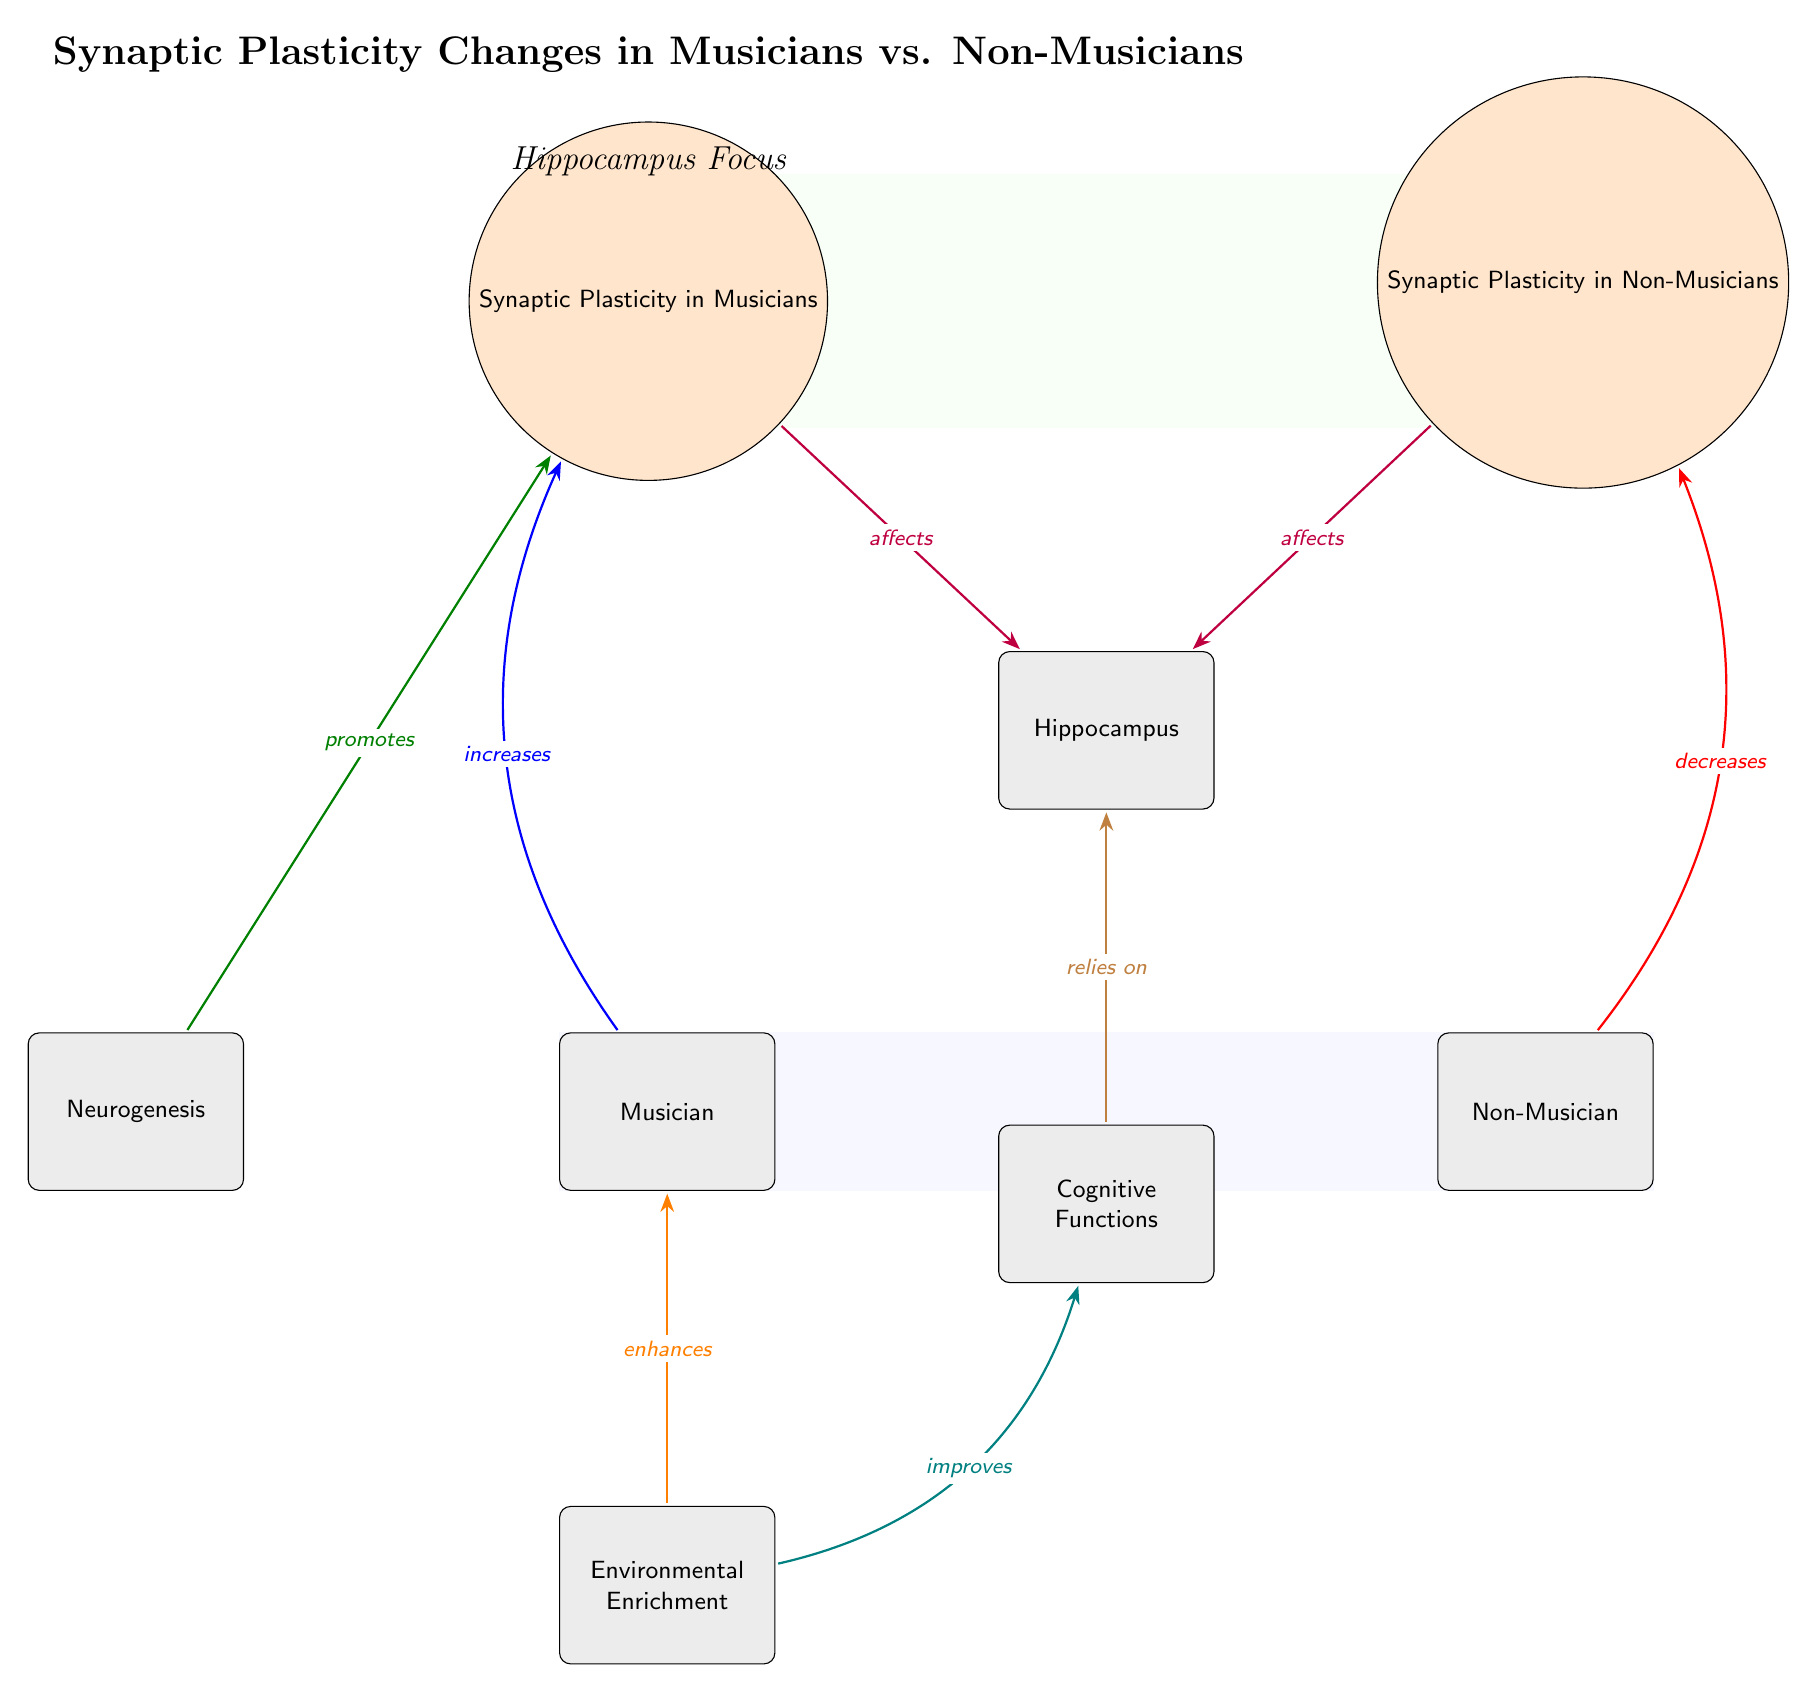What are the two main types of individuals compared in the diagram? The diagram depicts two main types of individuals: Musicians and Non-Musicians, which are labeled as distinct entities at the lower left and lower right corners of the diagram, respectively.
Answer: Musicians and Non-Musicians How does synaptic plasticity in musicians affect the hippocampus? The arrow labeled "affects" flows from "Synaptic Plasticity in Musicians" to "Hippocampus," indicating that synaptic plasticity in musicians has a positive relationship with the hippocampus.
Answer: Affects What relationship type is shown between environmental enrichment and musicians? The arrow between "Environmental Enrichment" and "Musician" is labeled "enhances," establishing a clear supportive relationship where environmental enrichment enhances the condition of being a musician.
Answer: Enhances What is the direction of the relationship between neurogenesis and synaptic plasticity in musicians? The arrow moves from "Neurogenesis" to "Synaptic Plasticity in Musicians," labeled "promotes," which indicates the flow of influence from neurogenesis towards an increase in synaptic plasticity in musicians.
Answer: Promotes Which cognitive aspect is related to the hippocampus, according to the diagram? The arrow indicates a direct relationship from "Cognitive Functions" to "Hippocampus," labeled "relies on," meaning that cognitive functions depend on the hippocampus for their operation.
Answer: Relies on How do synaptic plasticity levels differ between musicians and non-musicians? The diagram indicates an increase in synaptic plasticity for musicians compared to a decrease for non-musicians, portrayed by the arrows labeled "increases" and "decreases," respectively.
Answer: Increases for musicians, decreases for non-musicians Which process is indicated as improving cognitive functions? The arrow labeled "improves" flows from "Environmental Enrichment" to "Cognitive Functions," denoting that the environmental factors can lead to an enhancement in cognitive performance.
Answer: Improves What type of diagram is this? The structure and elements present in this diagram emphasize the flow of synaptic plasticity changes among musicians and non-musicians, making it specifically a Biomedical Diagram.
Answer: Biomedical Diagram Which node is at the top center of the diagram? The node labeled "Synaptic Plasticity Changes in Musicians vs. Non-Musicians" is prominent at the top center, acting as the main title for the diagram.
Answer: Synaptic Plasticity Changes in Musicians vs. Non-Musicians 